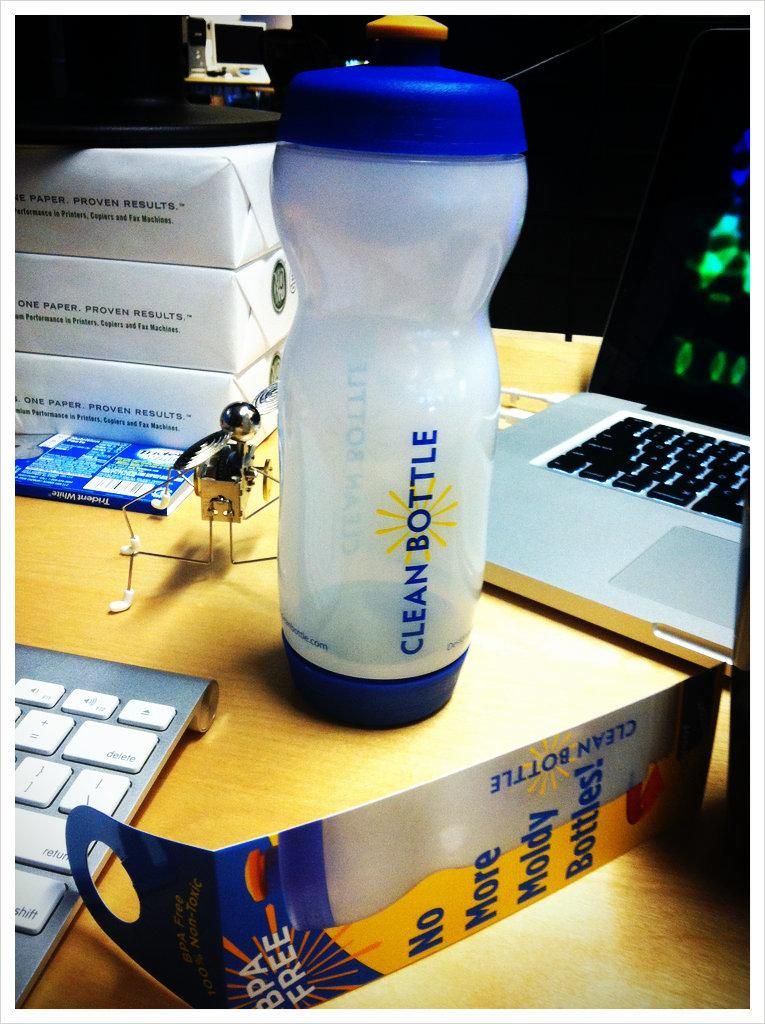<image>
Write a terse but informative summary of the picture. a water bottle labelled clean bottle on a desk 